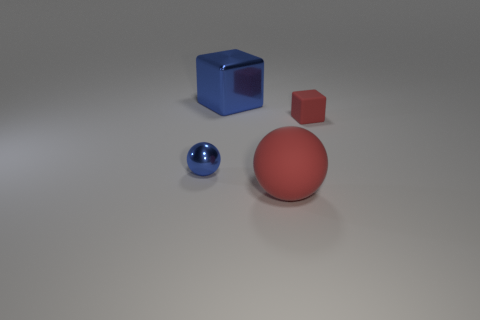Add 4 blue balls. How many objects exist? 8 Subtract all blue blocks. How many blocks are left? 1 Subtract 1 spheres. How many spheres are left? 1 Subtract all green balls. Subtract all yellow blocks. How many balls are left? 2 Subtract all tiny metal things. Subtract all matte cubes. How many objects are left? 2 Add 4 red objects. How many red objects are left? 6 Add 1 small blue objects. How many small blue objects exist? 2 Subtract 1 blue blocks. How many objects are left? 3 